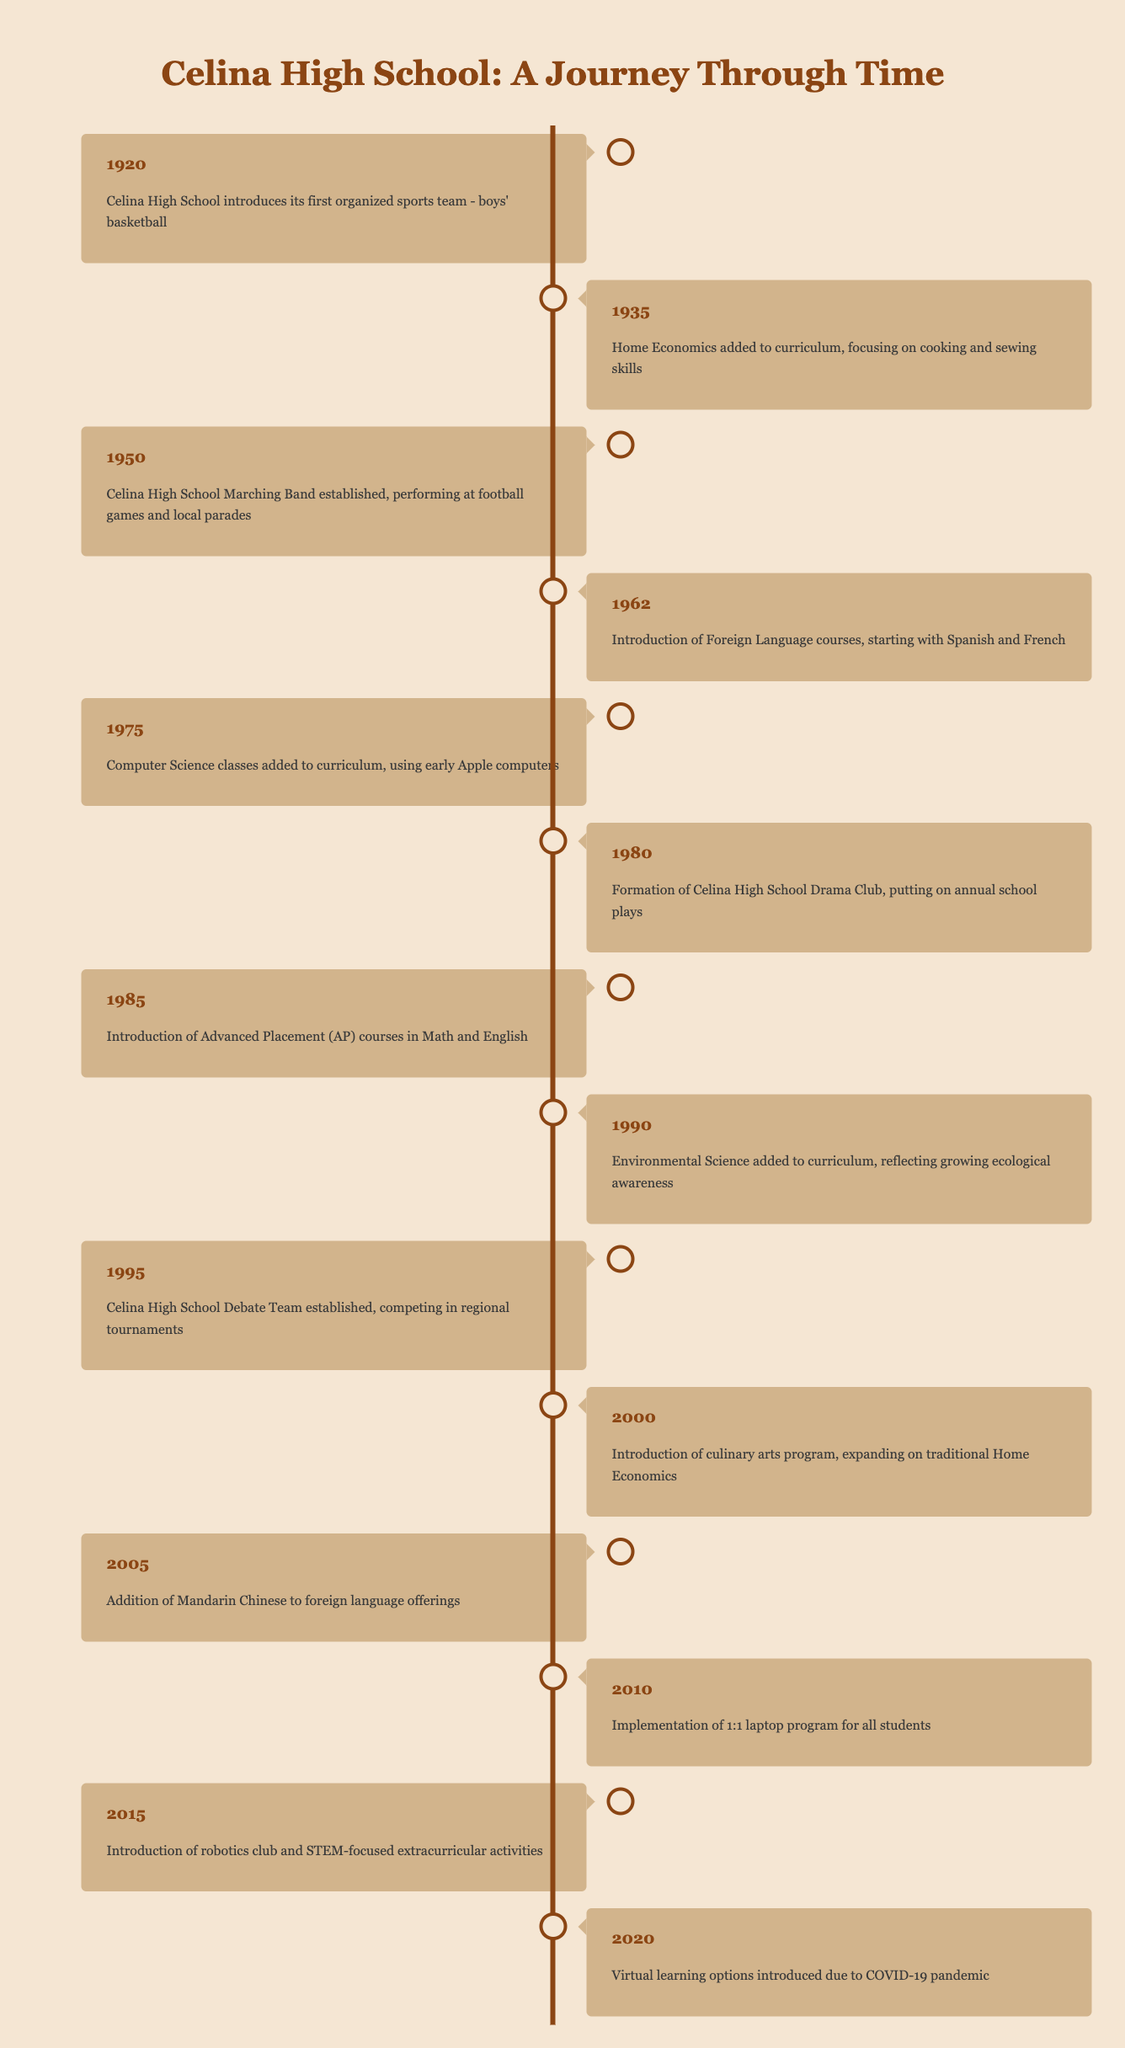What year did Celina High School introduce its first organized sports team? According to the timeline, the first organized sports team was introduced in 1920 with boys' basketball.
Answer: 1920 What new subject was added to the curriculum in 1935? The timeline indicates that in 1935, Home Economics was added to the curriculum, focusing on cooking and sewing skills.
Answer: Home Economics Was the Debate Team established before the introduction of the robotics club? From the timeline, the Debate Team was established in 1995, while the robotics club was introduced in 2015. Since 1995 is earlier than 2015, the statement is true.
Answer: Yes How many years passed between the introduction of Advanced Placement courses and the addition of Mandarin Chinese to the curriculum? Advanced Placement courses were introduced in 1985, and Mandarin Chinese was added in 2005. Subtracting the years gives 2005 - 1985 = 20 years.
Answer: 20 years What was added to the curriculum in 2000? The timeline states that in 2000, a culinary arts program was introduced, which expanded on traditional Home Economics.
Answer: Culinary arts program In what year did Celina High School implement a 1:1 laptop program? According to the timeline, the 1:1 laptop program for all students was implemented in 2010.
Answer: 2010 Did Celina High School have a Drama Club before it introduced Foreign Language courses? The timeline indicates the Drama Club was formed in 1980 and Foreign Language courses were introduced in 1962. Since 1980 is after 1962, this statement is false.
Answer: No What significant educational trend began in 1975 at Celina High School? The timeline shows that computer science classes were added to the curriculum in 1975, which was a significant educational trend during that time.
Answer: Computer science classes How many events listed in the timeline occurred after the establishment of the Marching Band? The Marching Band was established in 1950. Events occurring after that year are from 1962 (Foreign Language courses) to 2020 (Virtual learning options), totaling 10 events.
Answer: 10 events 